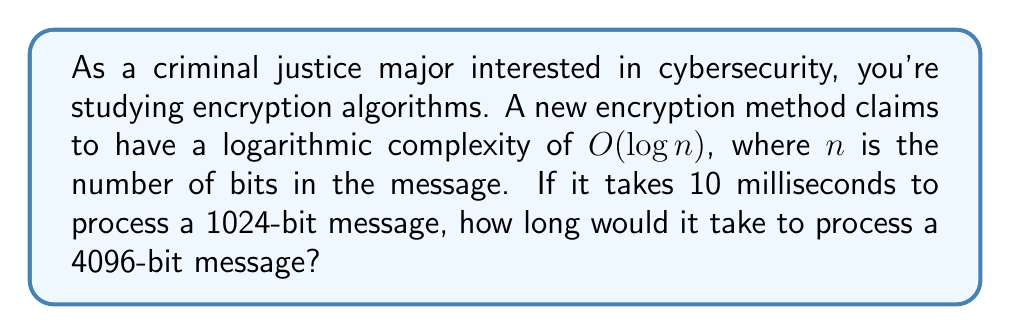Teach me how to tackle this problem. Let's approach this step-by-step:

1) The algorithm has a complexity of $O(\log n)$. This means the processing time is proportional to the logarithm of the input size.

2) We're given two data points:
   - For $n_1 = 1024$ bits, time $t_1 = 10$ ms
   - We need to find $t_2$ for $n_2 = 4096$ bits

3) The relationship between these can be expressed as:

   $$\frac{t_2}{t_1} = \frac{\log n_2}{\log n_1}$$

4) We can use any base for the logarithm, as long as it's consistent. Let's use base 2:

   $$\frac{t_2}{10} = \frac{\log_2 4096}{\log_2 1024}$$

5) Simplify:
   $$\frac{t_2}{10} = \frac{12}{10}$$

   This is because $4096 = 2^{12}$ and $1024 = 2^{10}$

6) Solve for $t_2$:
   $$t_2 = 10 \cdot \frac{12}{10} = 12$$

Therefore, it would take 12 milliseconds to process a 4096-bit message.
Answer: 12 milliseconds 